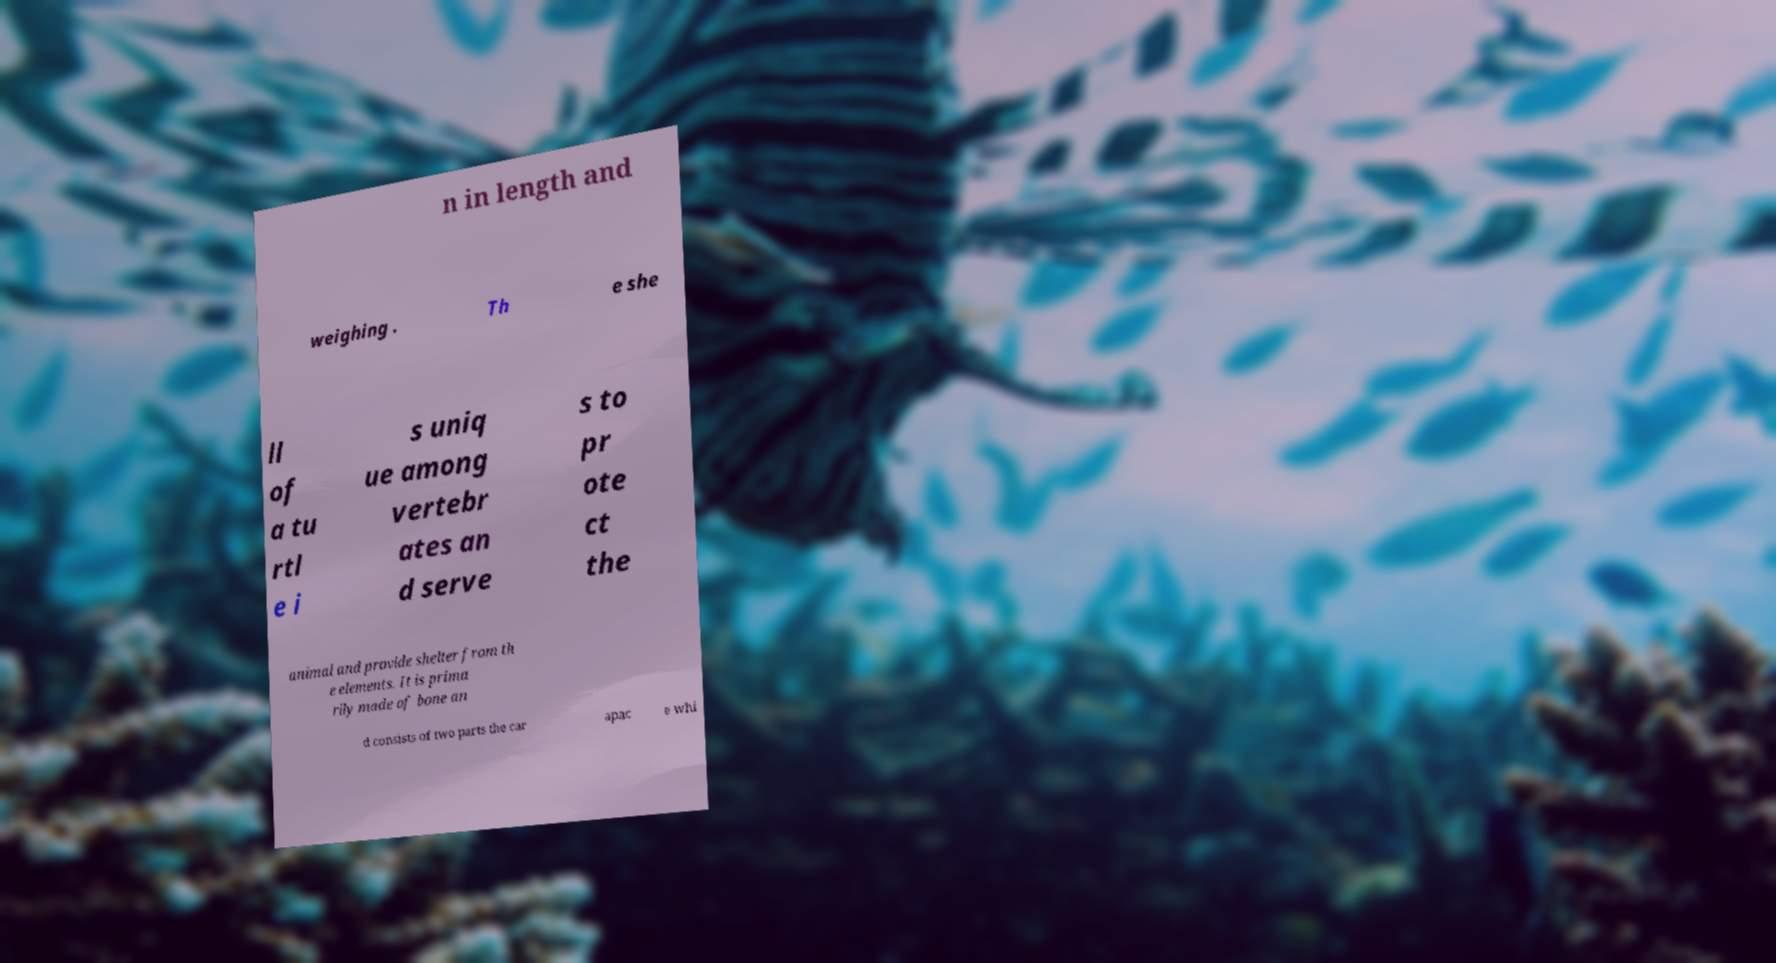Could you extract and type out the text from this image? n in length and weighing . Th e she ll of a tu rtl e i s uniq ue among vertebr ates an d serve s to pr ote ct the animal and provide shelter from th e elements. It is prima rily made of bone an d consists of two parts the car apac e whi 